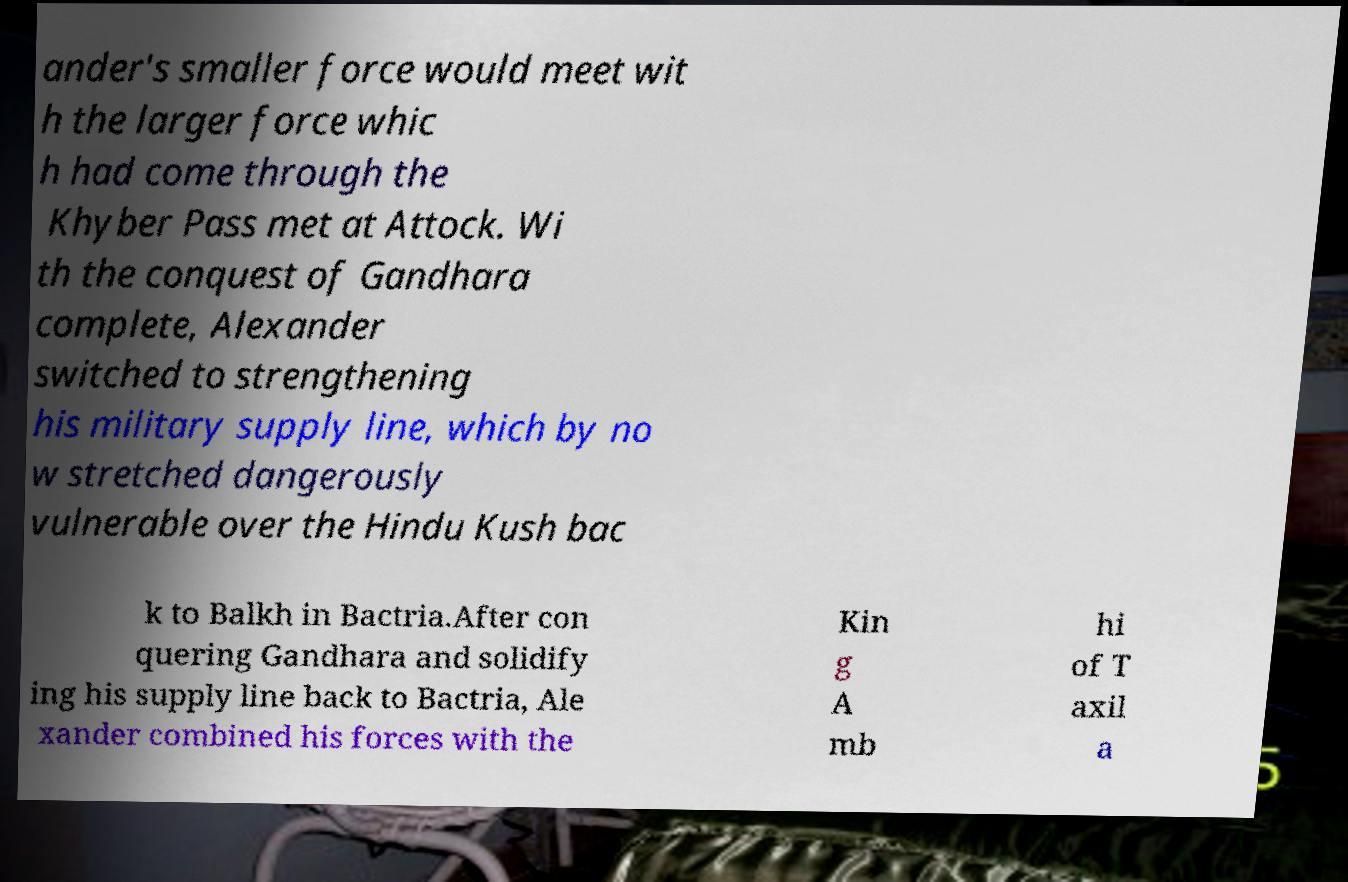There's text embedded in this image that I need extracted. Can you transcribe it verbatim? ander's smaller force would meet wit h the larger force whic h had come through the Khyber Pass met at Attock. Wi th the conquest of Gandhara complete, Alexander switched to strengthening his military supply line, which by no w stretched dangerously vulnerable over the Hindu Kush bac k to Balkh in Bactria.After con quering Gandhara and solidify ing his supply line back to Bactria, Ale xander combined his forces with the Kin g A mb hi of T axil a 